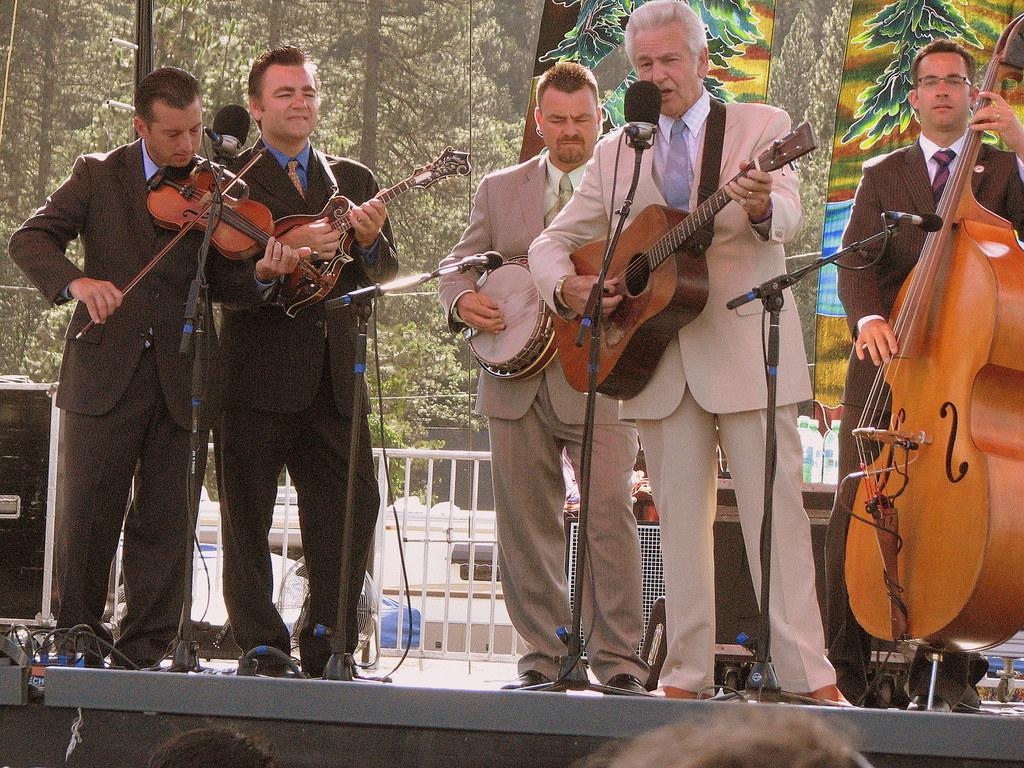What are the people in the image doing? The people in the image are playing musical instruments. Is there anyone in the group performing a different activity? Yes, one person is singing in front of a microphone. What can be seen in the background of the image? There are trees in the background of the image. What type of friction is present between the musical instruments in the image? There is no mention of friction in the image, as it focuses on the people playing musical instruments and singing. 